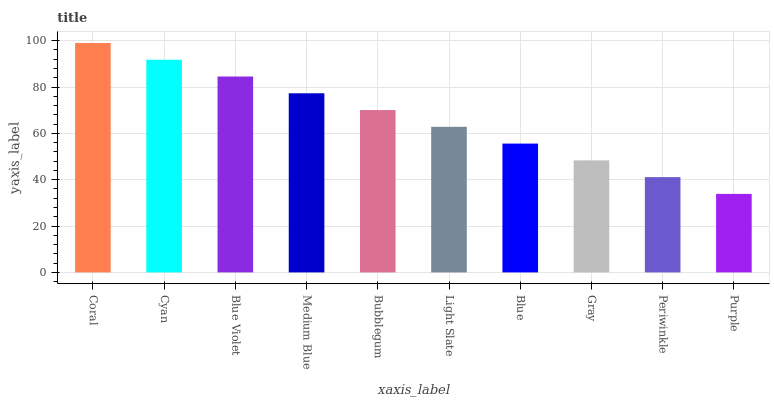Is Purple the minimum?
Answer yes or no. Yes. Is Coral the maximum?
Answer yes or no. Yes. Is Cyan the minimum?
Answer yes or no. No. Is Cyan the maximum?
Answer yes or no. No. Is Coral greater than Cyan?
Answer yes or no. Yes. Is Cyan less than Coral?
Answer yes or no. Yes. Is Cyan greater than Coral?
Answer yes or no. No. Is Coral less than Cyan?
Answer yes or no. No. Is Bubblegum the high median?
Answer yes or no. Yes. Is Light Slate the low median?
Answer yes or no. Yes. Is Light Slate the high median?
Answer yes or no. No. Is Bubblegum the low median?
Answer yes or no. No. 